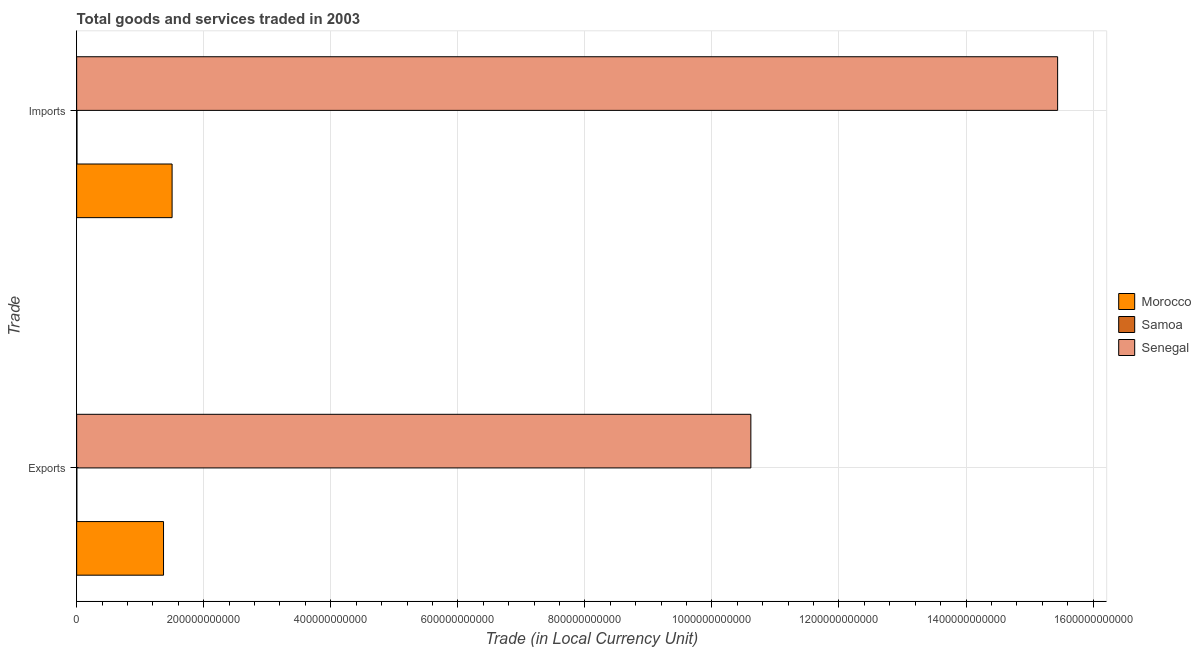Are the number of bars per tick equal to the number of legend labels?
Your response must be concise. Yes. Are the number of bars on each tick of the Y-axis equal?
Keep it short and to the point. Yes. How many bars are there on the 2nd tick from the bottom?
Provide a short and direct response. 3. What is the label of the 2nd group of bars from the top?
Your answer should be very brief. Exports. What is the imports of goods and services in Morocco?
Offer a very short reply. 1.50e+11. Across all countries, what is the maximum export of goods and services?
Give a very brief answer. 1.06e+12. Across all countries, what is the minimum export of goods and services?
Your answer should be very brief. 2.99e+08. In which country was the imports of goods and services maximum?
Your answer should be very brief. Senegal. In which country was the imports of goods and services minimum?
Keep it short and to the point. Samoa. What is the total export of goods and services in the graph?
Give a very brief answer. 1.20e+12. What is the difference between the imports of goods and services in Morocco and that in Senegal?
Provide a succinct answer. -1.39e+12. What is the difference between the imports of goods and services in Samoa and the export of goods and services in Morocco?
Offer a very short reply. -1.36e+11. What is the average export of goods and services per country?
Provide a succinct answer. 3.99e+11. What is the difference between the export of goods and services and imports of goods and services in Samoa?
Your answer should be compact. -2.17e+08. In how many countries, is the export of goods and services greater than 560000000000 LCU?
Your answer should be compact. 1. What is the ratio of the export of goods and services in Samoa to that in Senegal?
Offer a terse response. 0. Is the export of goods and services in Morocco less than that in Samoa?
Your answer should be very brief. No. What does the 3rd bar from the top in Imports represents?
Ensure brevity in your answer.  Morocco. What does the 1st bar from the bottom in Exports represents?
Provide a succinct answer. Morocco. How many bars are there?
Make the answer very short. 6. Are all the bars in the graph horizontal?
Your answer should be very brief. Yes. How many countries are there in the graph?
Ensure brevity in your answer.  3. What is the difference between two consecutive major ticks on the X-axis?
Offer a terse response. 2.00e+11. Does the graph contain any zero values?
Provide a short and direct response. No. Where does the legend appear in the graph?
Provide a short and direct response. Center right. What is the title of the graph?
Ensure brevity in your answer.  Total goods and services traded in 2003. What is the label or title of the X-axis?
Provide a short and direct response. Trade (in Local Currency Unit). What is the label or title of the Y-axis?
Make the answer very short. Trade. What is the Trade (in Local Currency Unit) of Morocco in Exports?
Provide a short and direct response. 1.37e+11. What is the Trade (in Local Currency Unit) in Samoa in Exports?
Offer a terse response. 2.99e+08. What is the Trade (in Local Currency Unit) of Senegal in Exports?
Offer a very short reply. 1.06e+12. What is the Trade (in Local Currency Unit) of Morocco in Imports?
Provide a short and direct response. 1.50e+11. What is the Trade (in Local Currency Unit) of Samoa in Imports?
Keep it short and to the point. 5.16e+08. What is the Trade (in Local Currency Unit) in Senegal in Imports?
Provide a succinct answer. 1.54e+12. Across all Trade, what is the maximum Trade (in Local Currency Unit) of Morocco?
Provide a short and direct response. 1.50e+11. Across all Trade, what is the maximum Trade (in Local Currency Unit) of Samoa?
Offer a terse response. 5.16e+08. Across all Trade, what is the maximum Trade (in Local Currency Unit) of Senegal?
Ensure brevity in your answer.  1.54e+12. Across all Trade, what is the minimum Trade (in Local Currency Unit) in Morocco?
Your answer should be compact. 1.37e+11. Across all Trade, what is the minimum Trade (in Local Currency Unit) in Samoa?
Keep it short and to the point. 2.99e+08. Across all Trade, what is the minimum Trade (in Local Currency Unit) of Senegal?
Offer a terse response. 1.06e+12. What is the total Trade (in Local Currency Unit) of Morocco in the graph?
Your response must be concise. 2.87e+11. What is the total Trade (in Local Currency Unit) in Samoa in the graph?
Ensure brevity in your answer.  8.15e+08. What is the total Trade (in Local Currency Unit) in Senegal in the graph?
Your answer should be very brief. 2.61e+12. What is the difference between the Trade (in Local Currency Unit) of Morocco in Exports and that in Imports?
Your answer should be very brief. -1.35e+1. What is the difference between the Trade (in Local Currency Unit) in Samoa in Exports and that in Imports?
Make the answer very short. -2.17e+08. What is the difference between the Trade (in Local Currency Unit) in Senegal in Exports and that in Imports?
Provide a succinct answer. -4.83e+11. What is the difference between the Trade (in Local Currency Unit) of Morocco in Exports and the Trade (in Local Currency Unit) of Samoa in Imports?
Ensure brevity in your answer.  1.36e+11. What is the difference between the Trade (in Local Currency Unit) of Morocco in Exports and the Trade (in Local Currency Unit) of Senegal in Imports?
Your answer should be compact. -1.41e+12. What is the difference between the Trade (in Local Currency Unit) of Samoa in Exports and the Trade (in Local Currency Unit) of Senegal in Imports?
Offer a very short reply. -1.54e+12. What is the average Trade (in Local Currency Unit) of Morocco per Trade?
Offer a terse response. 1.43e+11. What is the average Trade (in Local Currency Unit) in Samoa per Trade?
Your answer should be compact. 4.08e+08. What is the average Trade (in Local Currency Unit) in Senegal per Trade?
Your answer should be compact. 1.30e+12. What is the difference between the Trade (in Local Currency Unit) in Morocco and Trade (in Local Currency Unit) in Samoa in Exports?
Your answer should be very brief. 1.36e+11. What is the difference between the Trade (in Local Currency Unit) in Morocco and Trade (in Local Currency Unit) in Senegal in Exports?
Give a very brief answer. -9.25e+11. What is the difference between the Trade (in Local Currency Unit) of Samoa and Trade (in Local Currency Unit) of Senegal in Exports?
Offer a very short reply. -1.06e+12. What is the difference between the Trade (in Local Currency Unit) of Morocco and Trade (in Local Currency Unit) of Samoa in Imports?
Your answer should be very brief. 1.50e+11. What is the difference between the Trade (in Local Currency Unit) of Morocco and Trade (in Local Currency Unit) of Senegal in Imports?
Offer a very short reply. -1.39e+12. What is the difference between the Trade (in Local Currency Unit) of Samoa and Trade (in Local Currency Unit) of Senegal in Imports?
Provide a succinct answer. -1.54e+12. What is the ratio of the Trade (in Local Currency Unit) in Morocco in Exports to that in Imports?
Your answer should be compact. 0.91. What is the ratio of the Trade (in Local Currency Unit) in Samoa in Exports to that in Imports?
Make the answer very short. 0.58. What is the ratio of the Trade (in Local Currency Unit) in Senegal in Exports to that in Imports?
Give a very brief answer. 0.69. What is the difference between the highest and the second highest Trade (in Local Currency Unit) of Morocco?
Offer a very short reply. 1.35e+1. What is the difference between the highest and the second highest Trade (in Local Currency Unit) in Samoa?
Keep it short and to the point. 2.17e+08. What is the difference between the highest and the second highest Trade (in Local Currency Unit) of Senegal?
Your answer should be very brief. 4.83e+11. What is the difference between the highest and the lowest Trade (in Local Currency Unit) in Morocco?
Provide a short and direct response. 1.35e+1. What is the difference between the highest and the lowest Trade (in Local Currency Unit) of Samoa?
Ensure brevity in your answer.  2.17e+08. What is the difference between the highest and the lowest Trade (in Local Currency Unit) in Senegal?
Offer a terse response. 4.83e+11. 